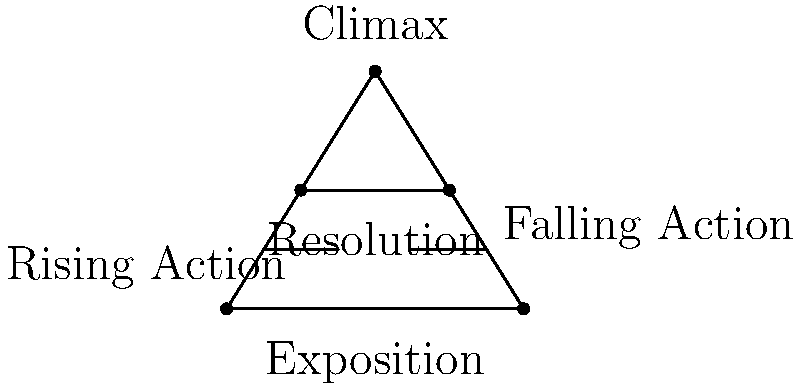As a novelist who values discretion in your writing process, how would you describe the stage of plot development where the main conflict reaches its highest point of tension, as represented in the pyramid diagram? To answer this question, let's analyze the plot structure pyramid diagram:

1. The pyramid diagram represents the classic five-act structure of a story.
2. The structure is divided into five parts, from bottom to top:
   a. Exposition
   b. Rising Action
   c. Climax
   d. Falling Action
   e. Resolution
3. The question asks about the stage where the main conflict reaches its highest point of tension.
4. In the diagram, this point is represented by the apex of the pyramid.
5. The apex is labeled "Climax," which is the correct term for this stage of plot development.
6. The Climax is where:
   - The story reaches its peak tension
   - The main conflict comes to a head
   - The protagonist faces their greatest challenge
   - The outcome of the story hangs in the balance
7. For a novelist who values discretion, the Climax is a crucial point that they would carefully craft and guard until the work is ready for public consumption.
Answer: Climax 